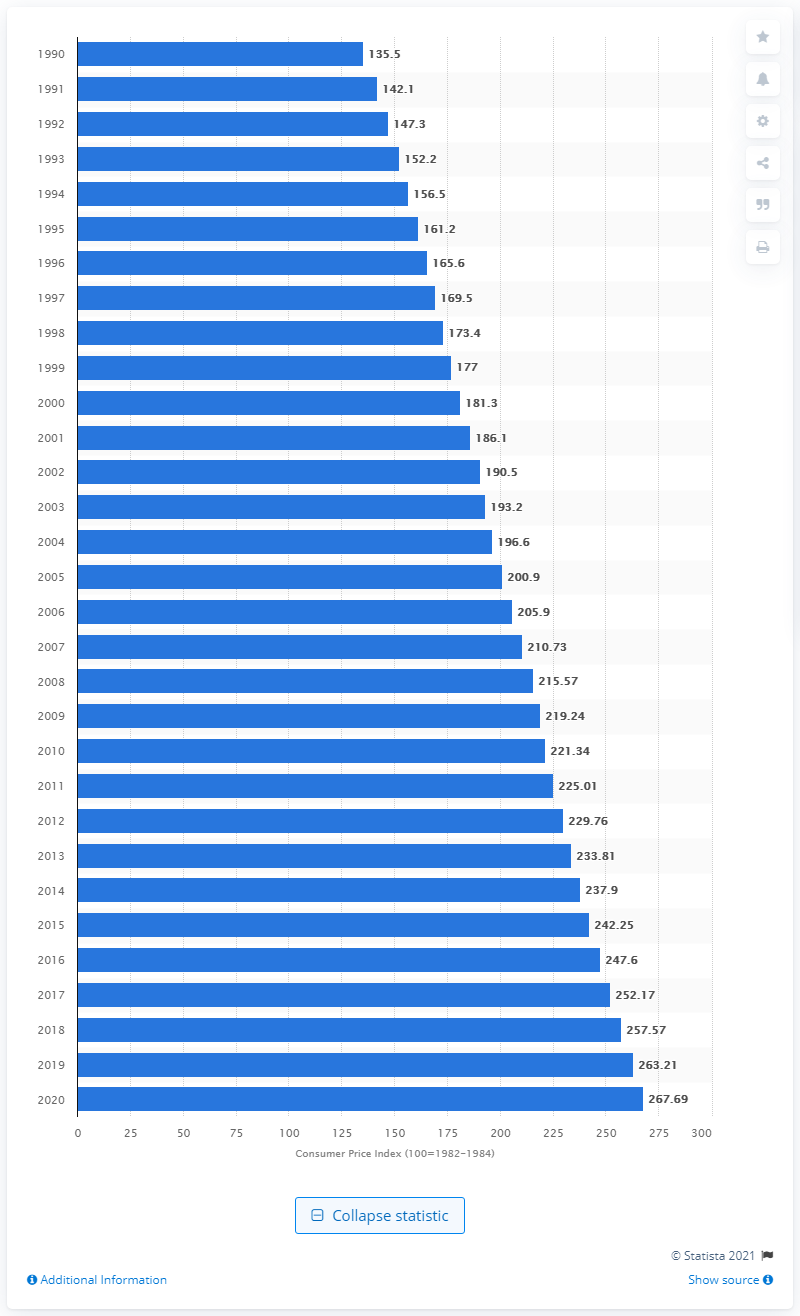Give some essential details in this illustration. The annual inflation rate in the United States began to increase in 1990. In 2020, the Consumer Price Index (CPI) was 267.69. 